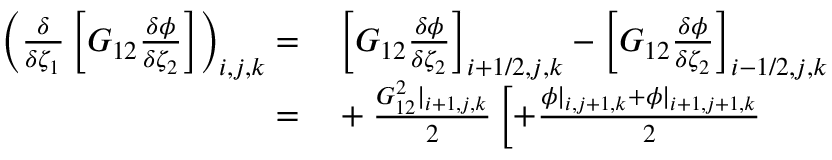Convert formula to latex. <formula><loc_0><loc_0><loc_500><loc_500>\begin{array} { r l } { \left ( \frac { \delta } { \delta \zeta _ { 1 } } \left [ G _ { 1 2 } \frac { \delta \phi } { \delta \zeta _ { 2 } } \right ] \right ) _ { i , j , k } = } & \left [ G _ { 1 2 } \frac { \delta \phi } { \delta \zeta _ { 2 } } \right ] _ { i + 1 / 2 , j , k } - \left [ G _ { 1 2 } \frac { \delta \phi } { \delta \zeta _ { 2 } } \right ] _ { i - 1 / 2 , j , k } } \\ { = } & + \frac { G _ { 1 2 } ^ { 2 } | _ { i + 1 , j , k } } { 2 } \left [ + \frac { \phi | _ { i , j + 1 , k } + \phi | _ { i + 1 , j + 1 , k } } { 2 } } \end{array}</formula> 